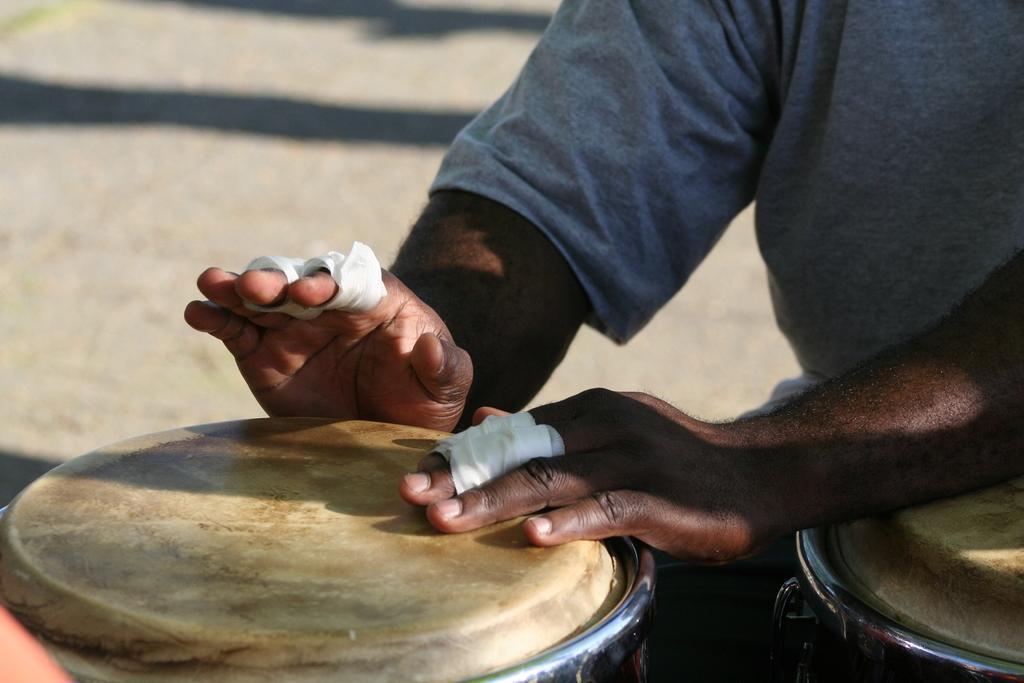Please provide a concise description of this image. A man is beating the drums he wore t-shirt. 